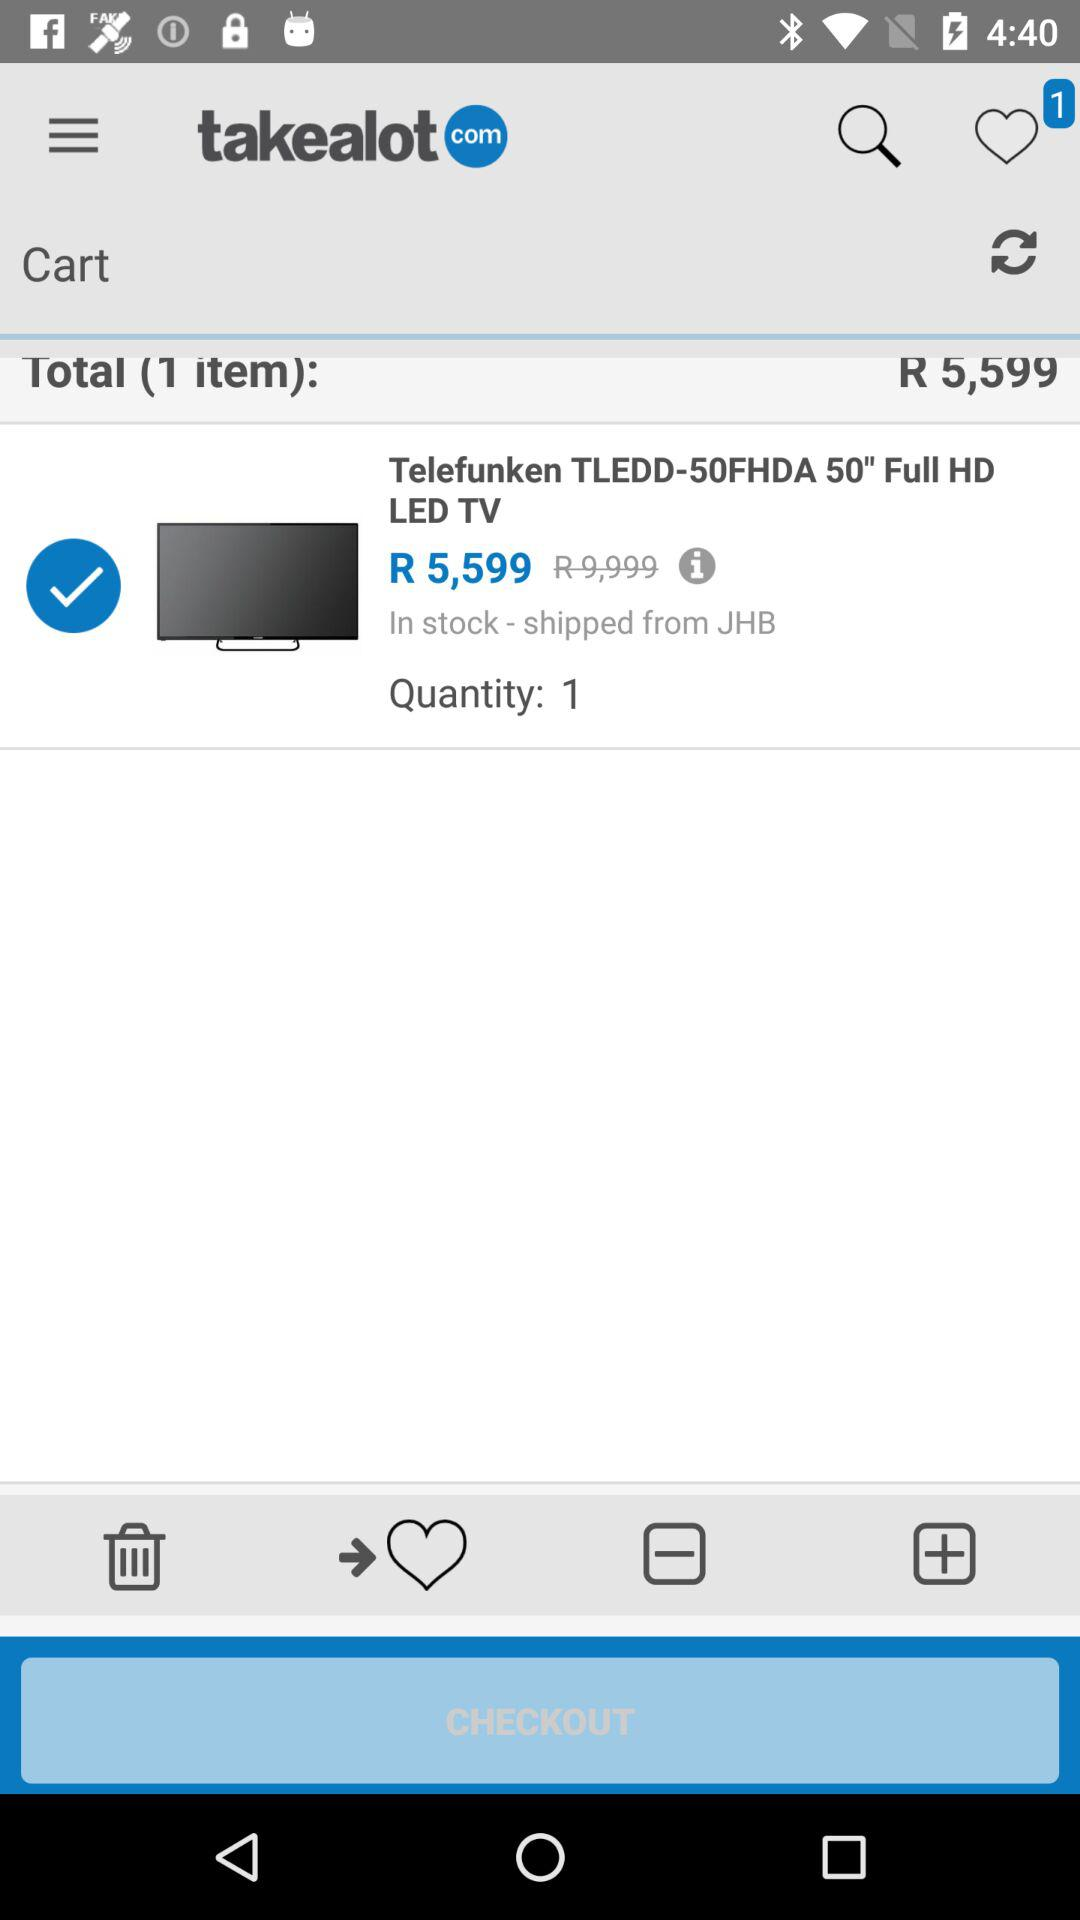What is the name of the application? The name of the application is "takealot". 